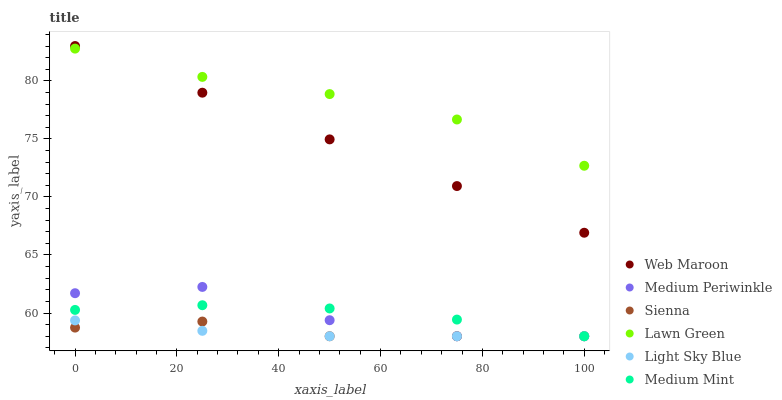Does Light Sky Blue have the minimum area under the curve?
Answer yes or no. Yes. Does Lawn Green have the maximum area under the curve?
Answer yes or no. Yes. Does Web Maroon have the minimum area under the curve?
Answer yes or no. No. Does Web Maroon have the maximum area under the curve?
Answer yes or no. No. Is Web Maroon the smoothest?
Answer yes or no. Yes. Is Medium Periwinkle the roughest?
Answer yes or no. Yes. Is Lawn Green the smoothest?
Answer yes or no. No. Is Lawn Green the roughest?
Answer yes or no. No. Does Medium Mint have the lowest value?
Answer yes or no. Yes. Does Web Maroon have the lowest value?
Answer yes or no. No. Does Web Maroon have the highest value?
Answer yes or no. Yes. Does Lawn Green have the highest value?
Answer yes or no. No. Is Light Sky Blue less than Web Maroon?
Answer yes or no. Yes. Is Web Maroon greater than Light Sky Blue?
Answer yes or no. Yes. Does Medium Periwinkle intersect Medium Mint?
Answer yes or no. Yes. Is Medium Periwinkle less than Medium Mint?
Answer yes or no. No. Is Medium Periwinkle greater than Medium Mint?
Answer yes or no. No. Does Light Sky Blue intersect Web Maroon?
Answer yes or no. No. 